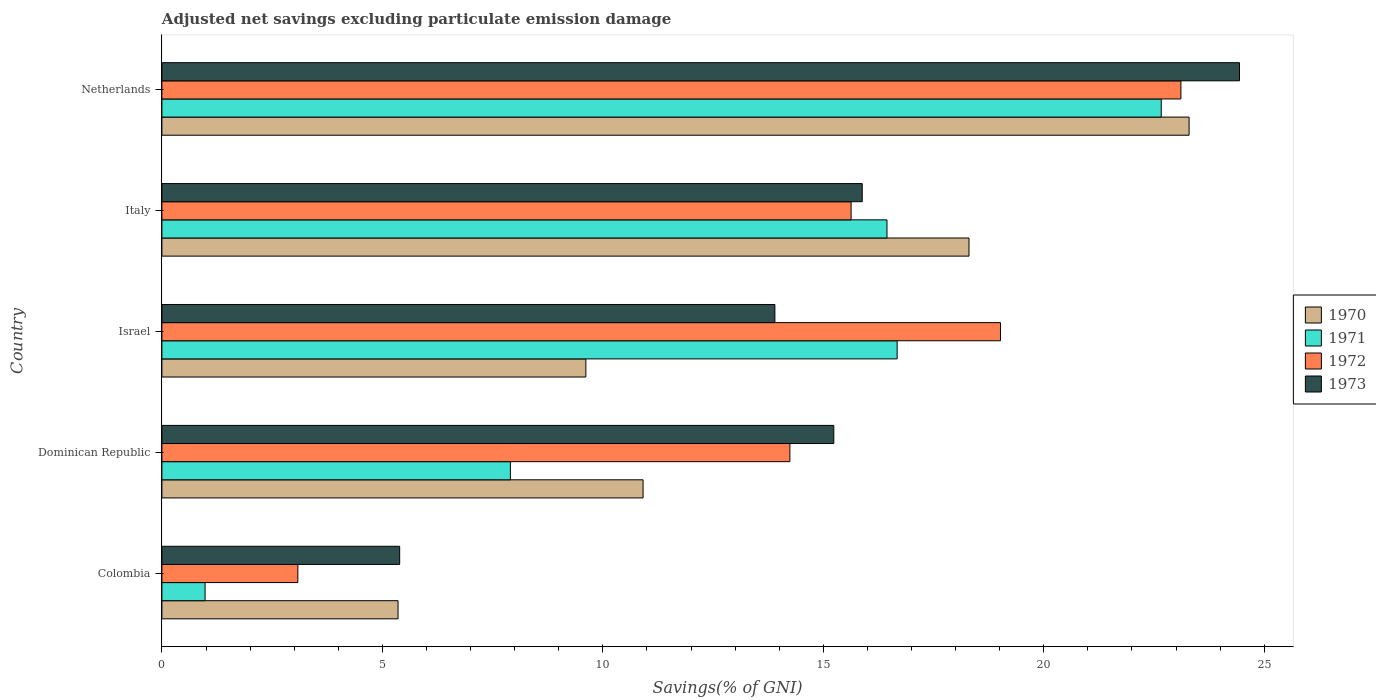Are the number of bars on each tick of the Y-axis equal?
Your answer should be very brief. Yes. What is the label of the 5th group of bars from the top?
Offer a terse response. Colombia. What is the adjusted net savings in 1971 in Netherlands?
Make the answer very short. 22.66. Across all countries, what is the maximum adjusted net savings in 1973?
Give a very brief answer. 24.44. Across all countries, what is the minimum adjusted net savings in 1973?
Provide a succinct answer. 5.39. In which country was the adjusted net savings in 1970 maximum?
Offer a very short reply. Netherlands. In which country was the adjusted net savings in 1971 minimum?
Keep it short and to the point. Colombia. What is the total adjusted net savings in 1970 in the graph?
Ensure brevity in your answer.  67.48. What is the difference between the adjusted net savings in 1971 in Dominican Republic and that in Israel?
Your answer should be very brief. -8.77. What is the difference between the adjusted net savings in 1972 in Italy and the adjusted net savings in 1973 in Colombia?
Make the answer very short. 10.24. What is the average adjusted net savings in 1971 per country?
Offer a terse response. 12.93. What is the difference between the adjusted net savings in 1970 and adjusted net savings in 1973 in Italy?
Offer a terse response. 2.42. What is the ratio of the adjusted net savings in 1971 in Colombia to that in Italy?
Provide a short and direct response. 0.06. What is the difference between the highest and the second highest adjusted net savings in 1972?
Your response must be concise. 4.09. What is the difference between the highest and the lowest adjusted net savings in 1973?
Offer a terse response. 19.05. Is the sum of the adjusted net savings in 1971 in Israel and Italy greater than the maximum adjusted net savings in 1972 across all countries?
Ensure brevity in your answer.  Yes. What does the 3rd bar from the bottom in Colombia represents?
Keep it short and to the point. 1972. Is it the case that in every country, the sum of the adjusted net savings in 1971 and adjusted net savings in 1973 is greater than the adjusted net savings in 1972?
Your answer should be very brief. Yes. Are the values on the major ticks of X-axis written in scientific E-notation?
Your answer should be very brief. No. Does the graph contain any zero values?
Give a very brief answer. No. Does the graph contain grids?
Give a very brief answer. No. How are the legend labels stacked?
Ensure brevity in your answer.  Vertical. What is the title of the graph?
Ensure brevity in your answer.  Adjusted net savings excluding particulate emission damage. Does "2009" appear as one of the legend labels in the graph?
Your answer should be compact. No. What is the label or title of the X-axis?
Make the answer very short. Savings(% of GNI). What is the Savings(% of GNI) of 1970 in Colombia?
Provide a succinct answer. 5.36. What is the Savings(% of GNI) in 1971 in Colombia?
Your answer should be compact. 0.98. What is the Savings(% of GNI) of 1972 in Colombia?
Your answer should be compact. 3.08. What is the Savings(% of GNI) of 1973 in Colombia?
Ensure brevity in your answer.  5.39. What is the Savings(% of GNI) in 1970 in Dominican Republic?
Keep it short and to the point. 10.91. What is the Savings(% of GNI) of 1971 in Dominican Republic?
Make the answer very short. 7.9. What is the Savings(% of GNI) in 1972 in Dominican Republic?
Provide a short and direct response. 14.24. What is the Savings(% of GNI) in 1973 in Dominican Republic?
Ensure brevity in your answer.  15.24. What is the Savings(% of GNI) of 1970 in Israel?
Give a very brief answer. 9.61. What is the Savings(% of GNI) of 1971 in Israel?
Provide a short and direct response. 16.67. What is the Savings(% of GNI) in 1972 in Israel?
Your answer should be compact. 19.02. What is the Savings(% of GNI) in 1973 in Israel?
Your response must be concise. 13.9. What is the Savings(% of GNI) of 1970 in Italy?
Your answer should be very brief. 18.3. What is the Savings(% of GNI) of 1971 in Italy?
Provide a succinct answer. 16.44. What is the Savings(% of GNI) in 1972 in Italy?
Offer a terse response. 15.63. What is the Savings(% of GNI) of 1973 in Italy?
Offer a very short reply. 15.88. What is the Savings(% of GNI) in 1970 in Netherlands?
Provide a short and direct response. 23.3. What is the Savings(% of GNI) of 1971 in Netherlands?
Your answer should be very brief. 22.66. What is the Savings(% of GNI) of 1972 in Netherlands?
Your answer should be very brief. 23.11. What is the Savings(% of GNI) in 1973 in Netherlands?
Offer a very short reply. 24.44. Across all countries, what is the maximum Savings(% of GNI) of 1970?
Offer a very short reply. 23.3. Across all countries, what is the maximum Savings(% of GNI) of 1971?
Ensure brevity in your answer.  22.66. Across all countries, what is the maximum Savings(% of GNI) of 1972?
Your response must be concise. 23.11. Across all countries, what is the maximum Savings(% of GNI) of 1973?
Make the answer very short. 24.44. Across all countries, what is the minimum Savings(% of GNI) in 1970?
Ensure brevity in your answer.  5.36. Across all countries, what is the minimum Savings(% of GNI) of 1971?
Provide a succinct answer. 0.98. Across all countries, what is the minimum Savings(% of GNI) of 1972?
Your answer should be compact. 3.08. Across all countries, what is the minimum Savings(% of GNI) of 1973?
Offer a terse response. 5.39. What is the total Savings(% of GNI) of 1970 in the graph?
Ensure brevity in your answer.  67.48. What is the total Savings(% of GNI) in 1971 in the graph?
Give a very brief answer. 64.66. What is the total Savings(% of GNI) of 1972 in the graph?
Make the answer very short. 75.08. What is the total Savings(% of GNI) in 1973 in the graph?
Give a very brief answer. 74.85. What is the difference between the Savings(% of GNI) in 1970 in Colombia and that in Dominican Republic?
Your answer should be compact. -5.56. What is the difference between the Savings(% of GNI) of 1971 in Colombia and that in Dominican Republic?
Make the answer very short. -6.92. What is the difference between the Savings(% of GNI) of 1972 in Colombia and that in Dominican Republic?
Keep it short and to the point. -11.16. What is the difference between the Savings(% of GNI) of 1973 in Colombia and that in Dominican Republic?
Ensure brevity in your answer.  -9.85. What is the difference between the Savings(% of GNI) of 1970 in Colombia and that in Israel?
Provide a succinct answer. -4.26. What is the difference between the Savings(% of GNI) in 1971 in Colombia and that in Israel?
Provide a succinct answer. -15.7. What is the difference between the Savings(% of GNI) in 1972 in Colombia and that in Israel?
Provide a short and direct response. -15.94. What is the difference between the Savings(% of GNI) of 1973 in Colombia and that in Israel?
Keep it short and to the point. -8.51. What is the difference between the Savings(% of GNI) in 1970 in Colombia and that in Italy?
Offer a very short reply. -12.95. What is the difference between the Savings(% of GNI) in 1971 in Colombia and that in Italy?
Keep it short and to the point. -15.46. What is the difference between the Savings(% of GNI) of 1972 in Colombia and that in Italy?
Offer a terse response. -12.55. What is the difference between the Savings(% of GNI) of 1973 in Colombia and that in Italy?
Provide a succinct answer. -10.49. What is the difference between the Savings(% of GNI) of 1970 in Colombia and that in Netherlands?
Offer a very short reply. -17.94. What is the difference between the Savings(% of GNI) of 1971 in Colombia and that in Netherlands?
Provide a short and direct response. -21.68. What is the difference between the Savings(% of GNI) of 1972 in Colombia and that in Netherlands?
Provide a short and direct response. -20.03. What is the difference between the Savings(% of GNI) of 1973 in Colombia and that in Netherlands?
Make the answer very short. -19.05. What is the difference between the Savings(% of GNI) in 1970 in Dominican Republic and that in Israel?
Your answer should be compact. 1.3. What is the difference between the Savings(% of GNI) of 1971 in Dominican Republic and that in Israel?
Give a very brief answer. -8.77. What is the difference between the Savings(% of GNI) of 1972 in Dominican Republic and that in Israel?
Ensure brevity in your answer.  -4.78. What is the difference between the Savings(% of GNI) of 1973 in Dominican Republic and that in Israel?
Your response must be concise. 1.34. What is the difference between the Savings(% of GNI) in 1970 in Dominican Republic and that in Italy?
Ensure brevity in your answer.  -7.39. What is the difference between the Savings(% of GNI) of 1971 in Dominican Republic and that in Italy?
Offer a very short reply. -8.54. What is the difference between the Savings(% of GNI) of 1972 in Dominican Republic and that in Italy?
Offer a terse response. -1.39. What is the difference between the Savings(% of GNI) of 1973 in Dominican Republic and that in Italy?
Offer a terse response. -0.65. What is the difference between the Savings(% of GNI) of 1970 in Dominican Republic and that in Netherlands?
Keep it short and to the point. -12.38. What is the difference between the Savings(% of GNI) in 1971 in Dominican Republic and that in Netherlands?
Ensure brevity in your answer.  -14.76. What is the difference between the Savings(% of GNI) of 1972 in Dominican Republic and that in Netherlands?
Make the answer very short. -8.87. What is the difference between the Savings(% of GNI) of 1973 in Dominican Republic and that in Netherlands?
Make the answer very short. -9.2. What is the difference between the Savings(% of GNI) of 1970 in Israel and that in Italy?
Your answer should be compact. -8.69. What is the difference between the Savings(% of GNI) in 1971 in Israel and that in Italy?
Your answer should be compact. 0.23. What is the difference between the Savings(% of GNI) of 1972 in Israel and that in Italy?
Keep it short and to the point. 3.39. What is the difference between the Savings(% of GNI) in 1973 in Israel and that in Italy?
Provide a succinct answer. -1.98. What is the difference between the Savings(% of GNI) of 1970 in Israel and that in Netherlands?
Keep it short and to the point. -13.68. What is the difference between the Savings(% of GNI) of 1971 in Israel and that in Netherlands?
Your response must be concise. -5.99. What is the difference between the Savings(% of GNI) of 1972 in Israel and that in Netherlands?
Your response must be concise. -4.09. What is the difference between the Savings(% of GNI) of 1973 in Israel and that in Netherlands?
Ensure brevity in your answer.  -10.54. What is the difference between the Savings(% of GNI) of 1970 in Italy and that in Netherlands?
Offer a very short reply. -4.99. What is the difference between the Savings(% of GNI) in 1971 in Italy and that in Netherlands?
Provide a short and direct response. -6.22. What is the difference between the Savings(% of GNI) in 1972 in Italy and that in Netherlands?
Keep it short and to the point. -7.48. What is the difference between the Savings(% of GNI) in 1973 in Italy and that in Netherlands?
Provide a short and direct response. -8.56. What is the difference between the Savings(% of GNI) of 1970 in Colombia and the Savings(% of GNI) of 1971 in Dominican Republic?
Provide a succinct answer. -2.55. What is the difference between the Savings(% of GNI) of 1970 in Colombia and the Savings(% of GNI) of 1972 in Dominican Republic?
Provide a short and direct response. -8.89. What is the difference between the Savings(% of GNI) of 1970 in Colombia and the Savings(% of GNI) of 1973 in Dominican Republic?
Ensure brevity in your answer.  -9.88. What is the difference between the Savings(% of GNI) in 1971 in Colombia and the Savings(% of GNI) in 1972 in Dominican Republic?
Ensure brevity in your answer.  -13.26. What is the difference between the Savings(% of GNI) of 1971 in Colombia and the Savings(% of GNI) of 1973 in Dominican Republic?
Your response must be concise. -14.26. What is the difference between the Savings(% of GNI) of 1972 in Colombia and the Savings(% of GNI) of 1973 in Dominican Republic?
Keep it short and to the point. -12.15. What is the difference between the Savings(% of GNI) of 1970 in Colombia and the Savings(% of GNI) of 1971 in Israel?
Make the answer very short. -11.32. What is the difference between the Savings(% of GNI) of 1970 in Colombia and the Savings(% of GNI) of 1972 in Israel?
Ensure brevity in your answer.  -13.66. What is the difference between the Savings(% of GNI) in 1970 in Colombia and the Savings(% of GNI) in 1973 in Israel?
Provide a short and direct response. -8.55. What is the difference between the Savings(% of GNI) of 1971 in Colombia and the Savings(% of GNI) of 1972 in Israel?
Your answer should be very brief. -18.04. What is the difference between the Savings(% of GNI) of 1971 in Colombia and the Savings(% of GNI) of 1973 in Israel?
Ensure brevity in your answer.  -12.92. What is the difference between the Savings(% of GNI) of 1972 in Colombia and the Savings(% of GNI) of 1973 in Israel?
Make the answer very short. -10.82. What is the difference between the Savings(% of GNI) of 1970 in Colombia and the Savings(% of GNI) of 1971 in Italy?
Your answer should be compact. -11.09. What is the difference between the Savings(% of GNI) in 1970 in Colombia and the Savings(% of GNI) in 1972 in Italy?
Provide a succinct answer. -10.27. What is the difference between the Savings(% of GNI) of 1970 in Colombia and the Savings(% of GNI) of 1973 in Italy?
Give a very brief answer. -10.53. What is the difference between the Savings(% of GNI) of 1971 in Colombia and the Savings(% of GNI) of 1972 in Italy?
Ensure brevity in your answer.  -14.65. What is the difference between the Savings(% of GNI) in 1971 in Colombia and the Savings(% of GNI) in 1973 in Italy?
Your answer should be compact. -14.9. What is the difference between the Savings(% of GNI) in 1972 in Colombia and the Savings(% of GNI) in 1973 in Italy?
Your answer should be very brief. -12.8. What is the difference between the Savings(% of GNI) of 1970 in Colombia and the Savings(% of GNI) of 1971 in Netherlands?
Your response must be concise. -17.31. What is the difference between the Savings(% of GNI) in 1970 in Colombia and the Savings(% of GNI) in 1972 in Netherlands?
Offer a very short reply. -17.75. What is the difference between the Savings(% of GNI) in 1970 in Colombia and the Savings(% of GNI) in 1973 in Netherlands?
Ensure brevity in your answer.  -19.08. What is the difference between the Savings(% of GNI) in 1971 in Colombia and the Savings(% of GNI) in 1972 in Netherlands?
Your answer should be very brief. -22.13. What is the difference between the Savings(% of GNI) of 1971 in Colombia and the Savings(% of GNI) of 1973 in Netherlands?
Your response must be concise. -23.46. What is the difference between the Savings(% of GNI) of 1972 in Colombia and the Savings(% of GNI) of 1973 in Netherlands?
Your response must be concise. -21.36. What is the difference between the Savings(% of GNI) of 1970 in Dominican Republic and the Savings(% of GNI) of 1971 in Israel?
Your answer should be very brief. -5.76. What is the difference between the Savings(% of GNI) of 1970 in Dominican Republic and the Savings(% of GNI) of 1972 in Israel?
Give a very brief answer. -8.11. What is the difference between the Savings(% of GNI) in 1970 in Dominican Republic and the Savings(% of GNI) in 1973 in Israel?
Give a very brief answer. -2.99. What is the difference between the Savings(% of GNI) of 1971 in Dominican Republic and the Savings(% of GNI) of 1972 in Israel?
Offer a terse response. -11.11. What is the difference between the Savings(% of GNI) of 1971 in Dominican Republic and the Savings(% of GNI) of 1973 in Israel?
Ensure brevity in your answer.  -6. What is the difference between the Savings(% of GNI) in 1972 in Dominican Republic and the Savings(% of GNI) in 1973 in Israel?
Your answer should be very brief. 0.34. What is the difference between the Savings(% of GNI) in 1970 in Dominican Republic and the Savings(% of GNI) in 1971 in Italy?
Offer a very short reply. -5.53. What is the difference between the Savings(% of GNI) of 1970 in Dominican Republic and the Savings(% of GNI) of 1972 in Italy?
Offer a very short reply. -4.72. What is the difference between the Savings(% of GNI) in 1970 in Dominican Republic and the Savings(% of GNI) in 1973 in Italy?
Give a very brief answer. -4.97. What is the difference between the Savings(% of GNI) in 1971 in Dominican Republic and the Savings(% of GNI) in 1972 in Italy?
Offer a very short reply. -7.73. What is the difference between the Savings(% of GNI) of 1971 in Dominican Republic and the Savings(% of GNI) of 1973 in Italy?
Offer a terse response. -7.98. What is the difference between the Savings(% of GNI) of 1972 in Dominican Republic and the Savings(% of GNI) of 1973 in Italy?
Your answer should be very brief. -1.64. What is the difference between the Savings(% of GNI) in 1970 in Dominican Republic and the Savings(% of GNI) in 1971 in Netherlands?
Your answer should be very brief. -11.75. What is the difference between the Savings(% of GNI) of 1970 in Dominican Republic and the Savings(% of GNI) of 1972 in Netherlands?
Provide a succinct answer. -12.2. What is the difference between the Savings(% of GNI) in 1970 in Dominican Republic and the Savings(% of GNI) in 1973 in Netherlands?
Offer a terse response. -13.53. What is the difference between the Savings(% of GNI) in 1971 in Dominican Republic and the Savings(% of GNI) in 1972 in Netherlands?
Your response must be concise. -15.21. What is the difference between the Savings(% of GNI) of 1971 in Dominican Republic and the Savings(% of GNI) of 1973 in Netherlands?
Give a very brief answer. -16.53. What is the difference between the Savings(% of GNI) of 1972 in Dominican Republic and the Savings(% of GNI) of 1973 in Netherlands?
Provide a succinct answer. -10.2. What is the difference between the Savings(% of GNI) of 1970 in Israel and the Savings(% of GNI) of 1971 in Italy?
Make the answer very short. -6.83. What is the difference between the Savings(% of GNI) of 1970 in Israel and the Savings(% of GNI) of 1972 in Italy?
Offer a very short reply. -6.02. What is the difference between the Savings(% of GNI) of 1970 in Israel and the Savings(% of GNI) of 1973 in Italy?
Offer a terse response. -6.27. What is the difference between the Savings(% of GNI) in 1971 in Israel and the Savings(% of GNI) in 1972 in Italy?
Your answer should be very brief. 1.04. What is the difference between the Savings(% of GNI) of 1971 in Israel and the Savings(% of GNI) of 1973 in Italy?
Provide a succinct answer. 0.79. What is the difference between the Savings(% of GNI) in 1972 in Israel and the Savings(% of GNI) in 1973 in Italy?
Make the answer very short. 3.14. What is the difference between the Savings(% of GNI) in 1970 in Israel and the Savings(% of GNI) in 1971 in Netherlands?
Give a very brief answer. -13.05. What is the difference between the Savings(% of GNI) in 1970 in Israel and the Savings(% of GNI) in 1972 in Netherlands?
Keep it short and to the point. -13.49. What is the difference between the Savings(% of GNI) of 1970 in Israel and the Savings(% of GNI) of 1973 in Netherlands?
Your response must be concise. -14.82. What is the difference between the Savings(% of GNI) in 1971 in Israel and the Savings(% of GNI) in 1972 in Netherlands?
Provide a succinct answer. -6.44. What is the difference between the Savings(% of GNI) of 1971 in Israel and the Savings(% of GNI) of 1973 in Netherlands?
Offer a terse response. -7.76. What is the difference between the Savings(% of GNI) of 1972 in Israel and the Savings(% of GNI) of 1973 in Netherlands?
Ensure brevity in your answer.  -5.42. What is the difference between the Savings(% of GNI) in 1970 in Italy and the Savings(% of GNI) in 1971 in Netherlands?
Offer a terse response. -4.36. What is the difference between the Savings(% of GNI) in 1970 in Italy and the Savings(% of GNI) in 1972 in Netherlands?
Offer a terse response. -4.81. What is the difference between the Savings(% of GNI) in 1970 in Italy and the Savings(% of GNI) in 1973 in Netherlands?
Ensure brevity in your answer.  -6.13. What is the difference between the Savings(% of GNI) of 1971 in Italy and the Savings(% of GNI) of 1972 in Netherlands?
Keep it short and to the point. -6.67. What is the difference between the Savings(% of GNI) in 1971 in Italy and the Savings(% of GNI) in 1973 in Netherlands?
Ensure brevity in your answer.  -7.99. What is the difference between the Savings(% of GNI) of 1972 in Italy and the Savings(% of GNI) of 1973 in Netherlands?
Your answer should be very brief. -8.81. What is the average Savings(% of GNI) of 1970 per country?
Provide a short and direct response. 13.5. What is the average Savings(% of GNI) in 1971 per country?
Ensure brevity in your answer.  12.93. What is the average Savings(% of GNI) of 1972 per country?
Ensure brevity in your answer.  15.02. What is the average Savings(% of GNI) in 1973 per country?
Your answer should be compact. 14.97. What is the difference between the Savings(% of GNI) in 1970 and Savings(% of GNI) in 1971 in Colombia?
Make the answer very short. 4.38. What is the difference between the Savings(% of GNI) of 1970 and Savings(% of GNI) of 1972 in Colombia?
Ensure brevity in your answer.  2.27. What is the difference between the Savings(% of GNI) of 1970 and Savings(% of GNI) of 1973 in Colombia?
Offer a terse response. -0.04. What is the difference between the Savings(% of GNI) in 1971 and Savings(% of GNI) in 1972 in Colombia?
Your answer should be compact. -2.1. What is the difference between the Savings(% of GNI) of 1971 and Savings(% of GNI) of 1973 in Colombia?
Ensure brevity in your answer.  -4.41. What is the difference between the Savings(% of GNI) in 1972 and Savings(% of GNI) in 1973 in Colombia?
Your answer should be compact. -2.31. What is the difference between the Savings(% of GNI) of 1970 and Savings(% of GNI) of 1971 in Dominican Republic?
Your answer should be compact. 3.01. What is the difference between the Savings(% of GNI) of 1970 and Savings(% of GNI) of 1972 in Dominican Republic?
Offer a very short reply. -3.33. What is the difference between the Savings(% of GNI) of 1970 and Savings(% of GNI) of 1973 in Dominican Republic?
Provide a succinct answer. -4.33. What is the difference between the Savings(% of GNI) of 1971 and Savings(% of GNI) of 1972 in Dominican Republic?
Ensure brevity in your answer.  -6.34. What is the difference between the Savings(% of GNI) in 1971 and Savings(% of GNI) in 1973 in Dominican Republic?
Give a very brief answer. -7.33. What is the difference between the Savings(% of GNI) of 1972 and Savings(% of GNI) of 1973 in Dominican Republic?
Keep it short and to the point. -1. What is the difference between the Savings(% of GNI) of 1970 and Savings(% of GNI) of 1971 in Israel?
Offer a very short reply. -7.06. What is the difference between the Savings(% of GNI) of 1970 and Savings(% of GNI) of 1972 in Israel?
Provide a short and direct response. -9.4. What is the difference between the Savings(% of GNI) of 1970 and Savings(% of GNI) of 1973 in Israel?
Offer a terse response. -4.29. What is the difference between the Savings(% of GNI) in 1971 and Savings(% of GNI) in 1972 in Israel?
Your answer should be very brief. -2.34. What is the difference between the Savings(% of GNI) of 1971 and Savings(% of GNI) of 1973 in Israel?
Your response must be concise. 2.77. What is the difference between the Savings(% of GNI) of 1972 and Savings(% of GNI) of 1973 in Israel?
Offer a terse response. 5.12. What is the difference between the Savings(% of GNI) of 1970 and Savings(% of GNI) of 1971 in Italy?
Your response must be concise. 1.86. What is the difference between the Savings(% of GNI) of 1970 and Savings(% of GNI) of 1972 in Italy?
Your response must be concise. 2.67. What is the difference between the Savings(% of GNI) in 1970 and Savings(% of GNI) in 1973 in Italy?
Your answer should be compact. 2.42. What is the difference between the Savings(% of GNI) in 1971 and Savings(% of GNI) in 1972 in Italy?
Ensure brevity in your answer.  0.81. What is the difference between the Savings(% of GNI) of 1971 and Savings(% of GNI) of 1973 in Italy?
Your answer should be compact. 0.56. What is the difference between the Savings(% of GNI) in 1972 and Savings(% of GNI) in 1973 in Italy?
Provide a succinct answer. -0.25. What is the difference between the Savings(% of GNI) in 1970 and Savings(% of GNI) in 1971 in Netherlands?
Keep it short and to the point. 0.63. What is the difference between the Savings(% of GNI) in 1970 and Savings(% of GNI) in 1972 in Netherlands?
Your answer should be very brief. 0.19. What is the difference between the Savings(% of GNI) of 1970 and Savings(% of GNI) of 1973 in Netherlands?
Your response must be concise. -1.14. What is the difference between the Savings(% of GNI) in 1971 and Savings(% of GNI) in 1972 in Netherlands?
Make the answer very short. -0.45. What is the difference between the Savings(% of GNI) in 1971 and Savings(% of GNI) in 1973 in Netherlands?
Offer a terse response. -1.77. What is the difference between the Savings(% of GNI) in 1972 and Savings(% of GNI) in 1973 in Netherlands?
Offer a terse response. -1.33. What is the ratio of the Savings(% of GNI) in 1970 in Colombia to that in Dominican Republic?
Offer a very short reply. 0.49. What is the ratio of the Savings(% of GNI) of 1971 in Colombia to that in Dominican Republic?
Keep it short and to the point. 0.12. What is the ratio of the Savings(% of GNI) of 1972 in Colombia to that in Dominican Republic?
Ensure brevity in your answer.  0.22. What is the ratio of the Savings(% of GNI) in 1973 in Colombia to that in Dominican Republic?
Offer a very short reply. 0.35. What is the ratio of the Savings(% of GNI) of 1970 in Colombia to that in Israel?
Give a very brief answer. 0.56. What is the ratio of the Savings(% of GNI) in 1971 in Colombia to that in Israel?
Provide a short and direct response. 0.06. What is the ratio of the Savings(% of GNI) in 1972 in Colombia to that in Israel?
Offer a very short reply. 0.16. What is the ratio of the Savings(% of GNI) of 1973 in Colombia to that in Israel?
Give a very brief answer. 0.39. What is the ratio of the Savings(% of GNI) of 1970 in Colombia to that in Italy?
Offer a terse response. 0.29. What is the ratio of the Savings(% of GNI) of 1971 in Colombia to that in Italy?
Provide a succinct answer. 0.06. What is the ratio of the Savings(% of GNI) of 1972 in Colombia to that in Italy?
Your response must be concise. 0.2. What is the ratio of the Savings(% of GNI) of 1973 in Colombia to that in Italy?
Offer a terse response. 0.34. What is the ratio of the Savings(% of GNI) of 1970 in Colombia to that in Netherlands?
Your answer should be very brief. 0.23. What is the ratio of the Savings(% of GNI) in 1971 in Colombia to that in Netherlands?
Offer a terse response. 0.04. What is the ratio of the Savings(% of GNI) in 1972 in Colombia to that in Netherlands?
Ensure brevity in your answer.  0.13. What is the ratio of the Savings(% of GNI) of 1973 in Colombia to that in Netherlands?
Offer a terse response. 0.22. What is the ratio of the Savings(% of GNI) in 1970 in Dominican Republic to that in Israel?
Keep it short and to the point. 1.14. What is the ratio of the Savings(% of GNI) of 1971 in Dominican Republic to that in Israel?
Ensure brevity in your answer.  0.47. What is the ratio of the Savings(% of GNI) in 1972 in Dominican Republic to that in Israel?
Give a very brief answer. 0.75. What is the ratio of the Savings(% of GNI) of 1973 in Dominican Republic to that in Israel?
Provide a short and direct response. 1.1. What is the ratio of the Savings(% of GNI) in 1970 in Dominican Republic to that in Italy?
Make the answer very short. 0.6. What is the ratio of the Savings(% of GNI) in 1971 in Dominican Republic to that in Italy?
Give a very brief answer. 0.48. What is the ratio of the Savings(% of GNI) of 1972 in Dominican Republic to that in Italy?
Provide a succinct answer. 0.91. What is the ratio of the Savings(% of GNI) of 1973 in Dominican Republic to that in Italy?
Offer a terse response. 0.96. What is the ratio of the Savings(% of GNI) in 1970 in Dominican Republic to that in Netherlands?
Provide a succinct answer. 0.47. What is the ratio of the Savings(% of GNI) of 1971 in Dominican Republic to that in Netherlands?
Ensure brevity in your answer.  0.35. What is the ratio of the Savings(% of GNI) of 1972 in Dominican Republic to that in Netherlands?
Offer a very short reply. 0.62. What is the ratio of the Savings(% of GNI) of 1973 in Dominican Republic to that in Netherlands?
Make the answer very short. 0.62. What is the ratio of the Savings(% of GNI) of 1970 in Israel to that in Italy?
Ensure brevity in your answer.  0.53. What is the ratio of the Savings(% of GNI) of 1971 in Israel to that in Italy?
Your answer should be compact. 1.01. What is the ratio of the Savings(% of GNI) of 1972 in Israel to that in Italy?
Your answer should be very brief. 1.22. What is the ratio of the Savings(% of GNI) of 1973 in Israel to that in Italy?
Provide a short and direct response. 0.88. What is the ratio of the Savings(% of GNI) of 1970 in Israel to that in Netherlands?
Offer a very short reply. 0.41. What is the ratio of the Savings(% of GNI) in 1971 in Israel to that in Netherlands?
Offer a terse response. 0.74. What is the ratio of the Savings(% of GNI) in 1972 in Israel to that in Netherlands?
Give a very brief answer. 0.82. What is the ratio of the Savings(% of GNI) of 1973 in Israel to that in Netherlands?
Provide a short and direct response. 0.57. What is the ratio of the Savings(% of GNI) in 1970 in Italy to that in Netherlands?
Give a very brief answer. 0.79. What is the ratio of the Savings(% of GNI) of 1971 in Italy to that in Netherlands?
Offer a very short reply. 0.73. What is the ratio of the Savings(% of GNI) of 1972 in Italy to that in Netherlands?
Make the answer very short. 0.68. What is the ratio of the Savings(% of GNI) of 1973 in Italy to that in Netherlands?
Your answer should be compact. 0.65. What is the difference between the highest and the second highest Savings(% of GNI) of 1970?
Your answer should be very brief. 4.99. What is the difference between the highest and the second highest Savings(% of GNI) in 1971?
Provide a short and direct response. 5.99. What is the difference between the highest and the second highest Savings(% of GNI) of 1972?
Make the answer very short. 4.09. What is the difference between the highest and the second highest Savings(% of GNI) in 1973?
Your answer should be compact. 8.56. What is the difference between the highest and the lowest Savings(% of GNI) in 1970?
Ensure brevity in your answer.  17.94. What is the difference between the highest and the lowest Savings(% of GNI) in 1971?
Give a very brief answer. 21.68. What is the difference between the highest and the lowest Savings(% of GNI) in 1972?
Provide a short and direct response. 20.03. What is the difference between the highest and the lowest Savings(% of GNI) of 1973?
Your answer should be compact. 19.05. 